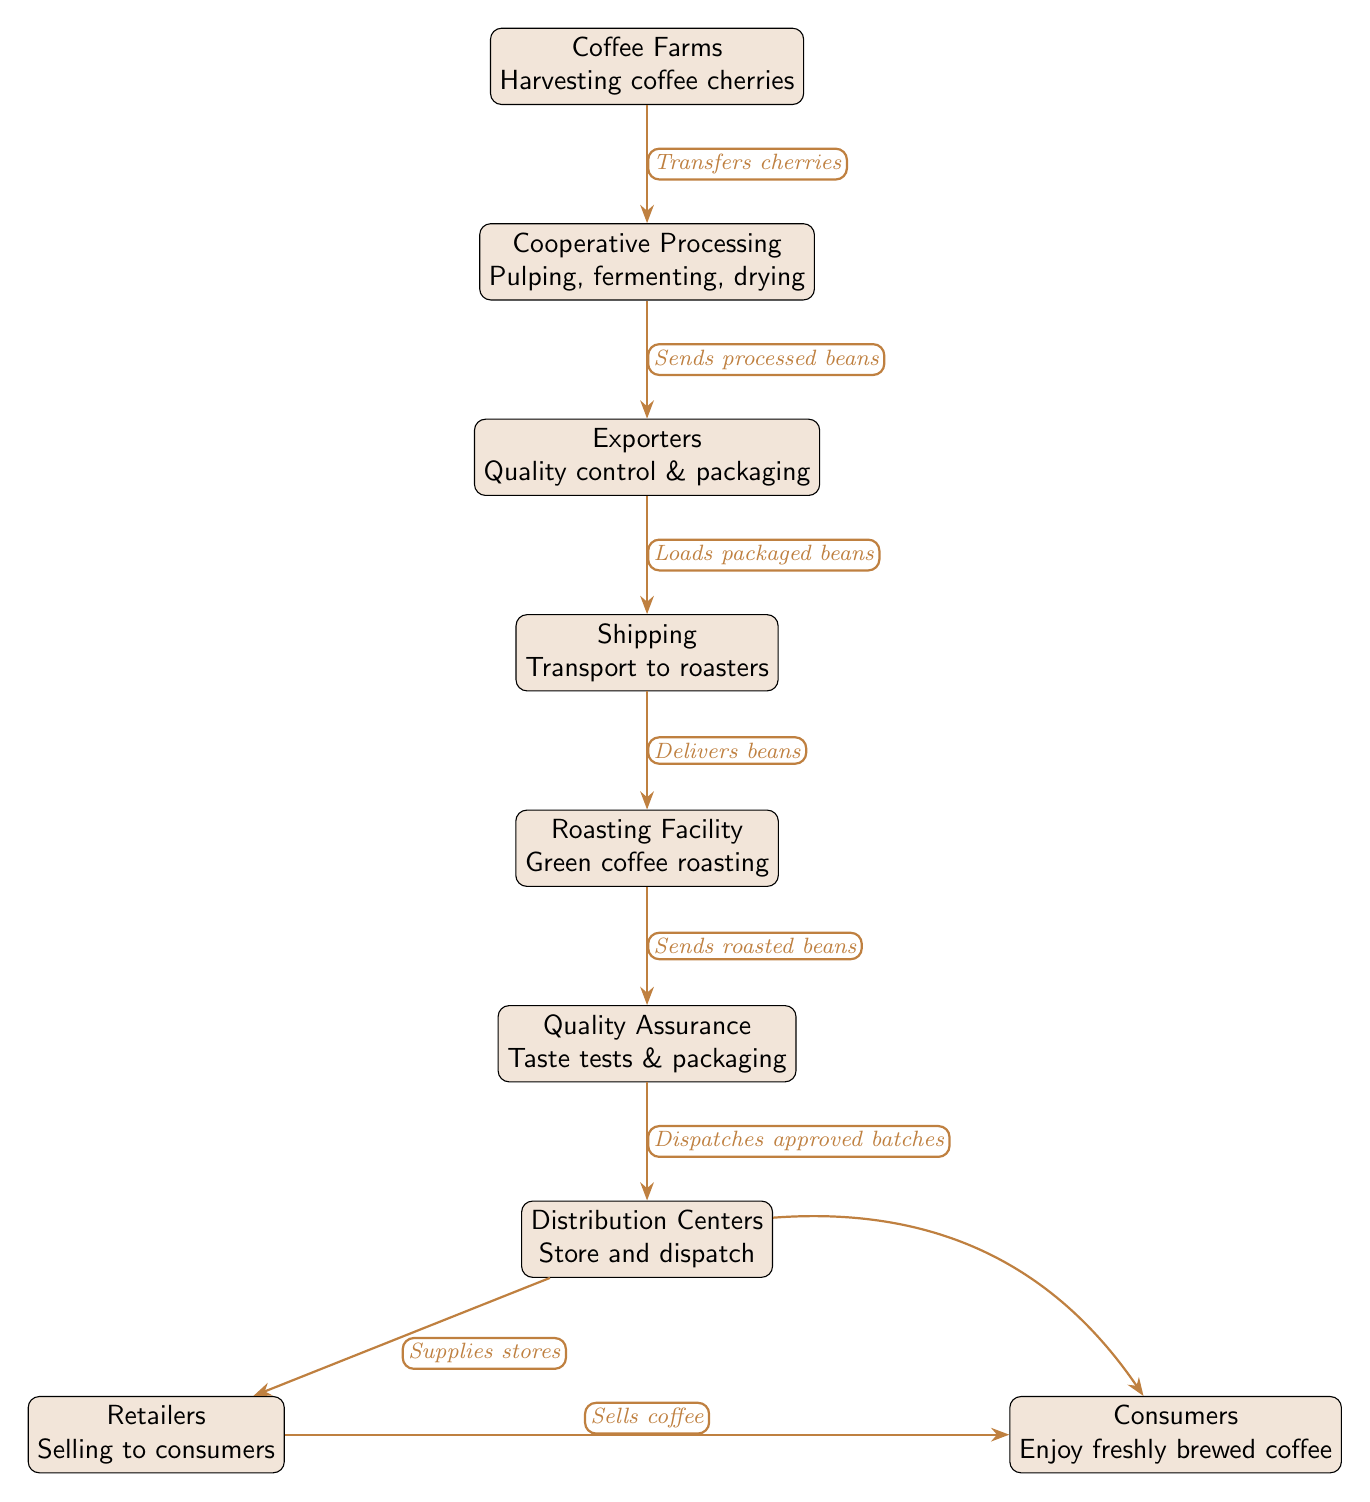What is the first step in the supply chain? The diagram indicates that the first step is "Coffee Farms" where coffee cherries are harvested. Hence, the first node establishes the starting point in the supply chain.
Answer: Coffee Farms How many nodes are present in the diagram? By counting each distinct functional component in the diagram from "Coffee Farms" to "Consumers," we find there are 8 nodes in total.
Answer: 8 What is the role of the "Cooperative Processing" node? The "Cooperative Processing" node is responsible for pulping, fermenting, and drying the coffee cherries. It's where the cherries are processed after being harvested on the farms.
Answer: Pulping, fermenting, drying Which node provides quality control and packaging? The "Exporters" node is the one that handles quality control and packaging of the processed coffee beans before they are shipped to roasters.
Answer: Exporters What happens after the "Roasting Facility"? After the "Roasting Facility," the flow goes to "Quality Assurance," where taste tests are conducted and packaging occurs before beans are sent to distribution centers.
Answer: Quality Assurance What is the connection between "Distribution Centers" and "Retailers"? The connection indicates that the "Distribution Centers" supplies stores, which corresponds to the retailers who sell the coffee to end consumers. The arrows represent this supply relationship.
Answer: Supplies stores What action is taken at the "Shipping" node? The "Shipping" node carries out the action of transporting the processed beans to the roasters, signifying the movement of goods in the supply chain.
Answer: Transport to roasters How do consumers receive the coffee? Consumers receive their coffee through retailers, where the "Retailers" sell the coffee, connecting consumers directly to the end product of the supply chain.
Answer: Sells coffee Which step comes immediately before the distribution of coffee to stores? The step that comes immediately before the distribution of coffee to stores is "Quality Assurance," where approved batches are dispatched to the distribution centers.
Answer: Quality Assurance 